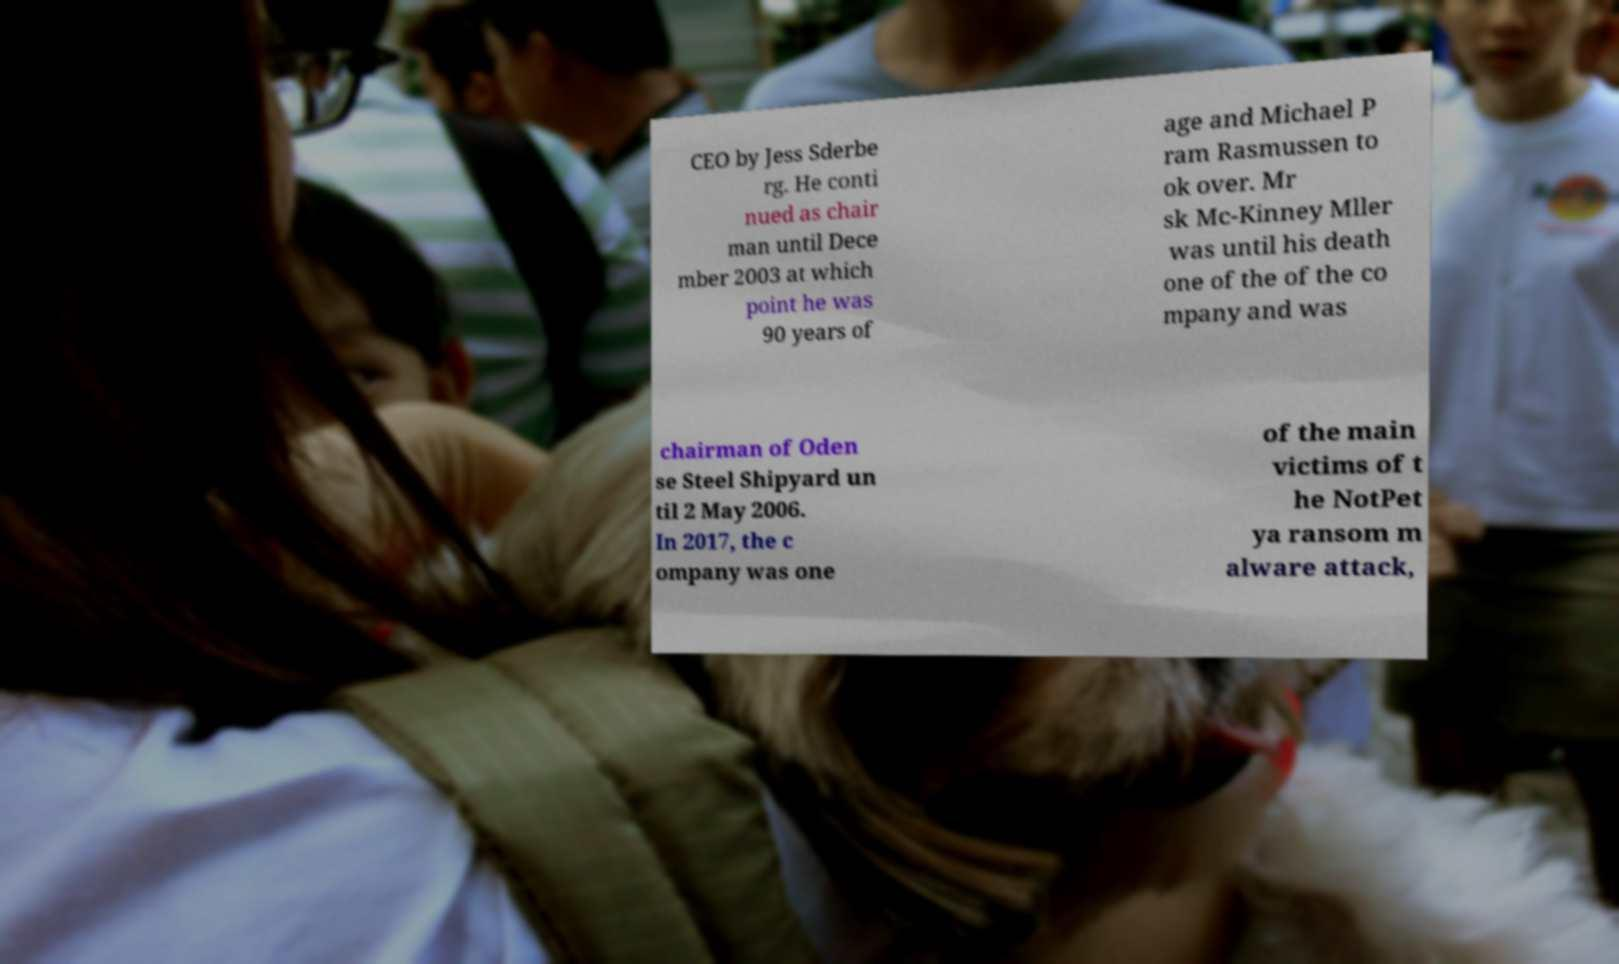Could you extract and type out the text from this image? CEO by Jess Sderbe rg. He conti nued as chair man until Dece mber 2003 at which point he was 90 years of age and Michael P ram Rasmussen to ok over. Mr sk Mc-Kinney Mller was until his death one of the of the co mpany and was chairman of Oden se Steel Shipyard un til 2 May 2006. In 2017, the c ompany was one of the main victims of t he NotPet ya ransom m alware attack, 